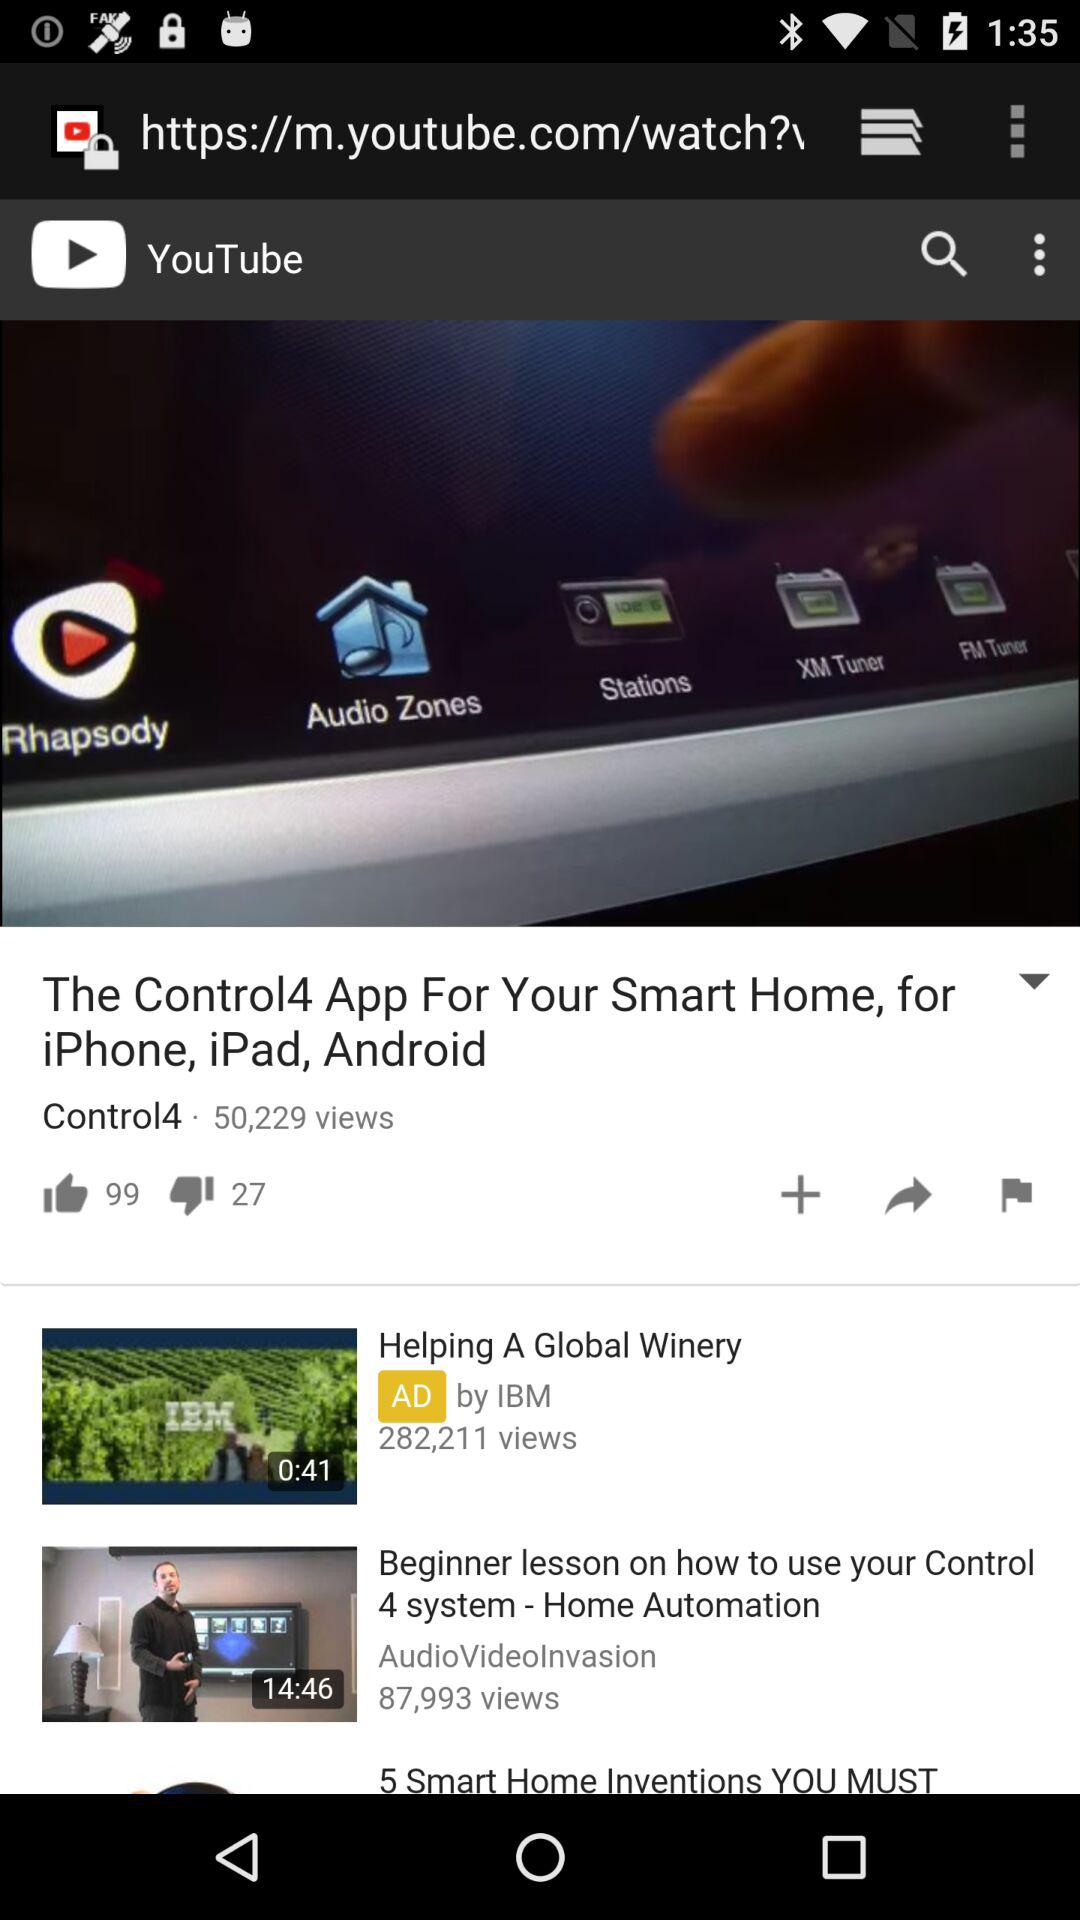How many likes are there of the video? There are 99 likes of the video. 